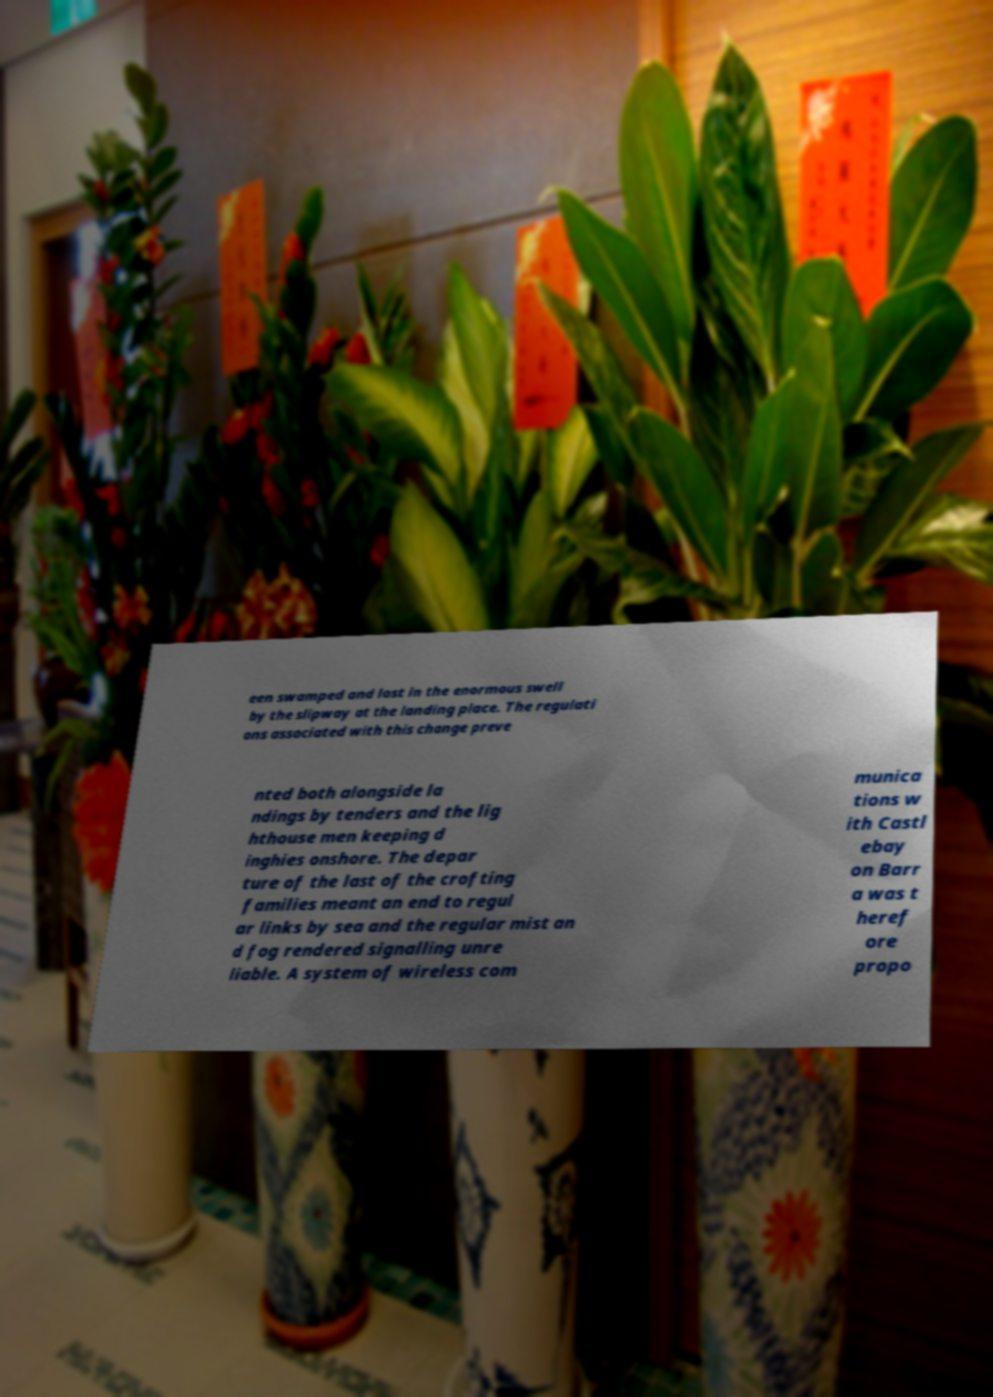Could you extract and type out the text from this image? een swamped and lost in the enormous swell by the slipway at the landing place. The regulati ons associated with this change preve nted both alongside la ndings by tenders and the lig hthouse men keeping d inghies onshore. The depar ture of the last of the crofting families meant an end to regul ar links by sea and the regular mist an d fog rendered signalling unre liable. A system of wireless com munica tions w ith Castl ebay on Barr a was t heref ore propo 